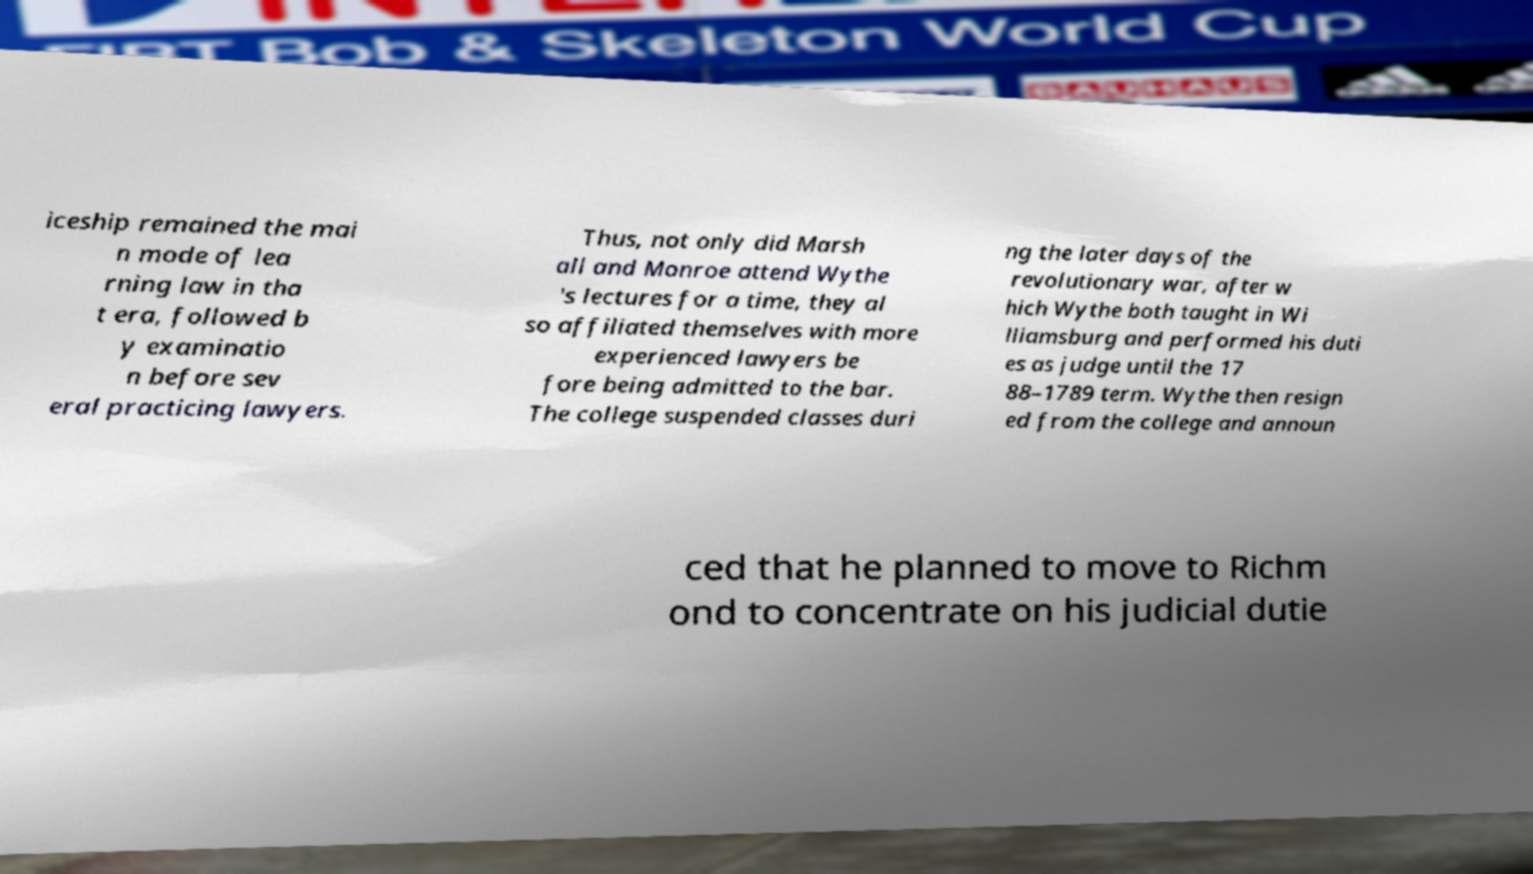Can you read and provide the text displayed in the image?This photo seems to have some interesting text. Can you extract and type it out for me? iceship remained the mai n mode of lea rning law in tha t era, followed b y examinatio n before sev eral practicing lawyers. Thus, not only did Marsh all and Monroe attend Wythe 's lectures for a time, they al so affiliated themselves with more experienced lawyers be fore being admitted to the bar. The college suspended classes duri ng the later days of the revolutionary war, after w hich Wythe both taught in Wi lliamsburg and performed his duti es as judge until the 17 88–1789 term. Wythe then resign ed from the college and announ ced that he planned to move to Richm ond to concentrate on his judicial dutie 